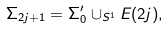Convert formula to latex. <formula><loc_0><loc_0><loc_500><loc_500>\Sigma _ { 2 j + 1 } = \Sigma _ { 0 } ^ { \prime } \cup _ { S ^ { 1 } } E ( 2 j ) ,</formula> 